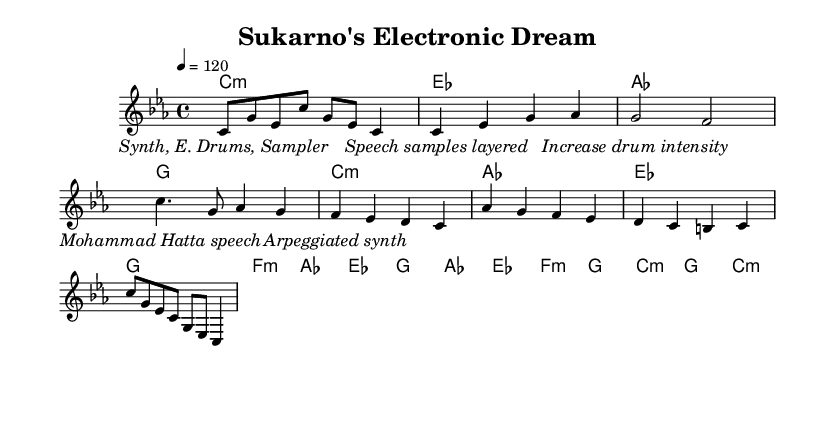What is the key signature of this music? The key signature shown at the beginning of the score indicates C minor, which has three flats (B♭, E♭, and A♭).
Answer: C minor What is the time signature of the piece? The time signature is indicated at the beginning of the score, showing four beats per measure.
Answer: 4/4 What is the tempo marking for this music? The tempo marking is found at the top of the score where it indicates a speed of 120 beats per minute, showing the intended performance speed.
Answer: 120 Which speech is featured in the bridge section? The lyrics in the bridge mention a specific speech; looking at the lyrics, it references Mohammad Hatta's speech.
Answer: Mohammad Hatta How many sections are there in this track? Analyzing the layout and structure of the score, we can identify five sections: Intro, Verse, Chorus, Bridge, and Outro.
Answer: Five In which part does the intensity of drums increase? The lyrics in the chorus mention an increase in drum intensity, indicating this is where the dynamics are expected to heighten.
Answer: Chorus 